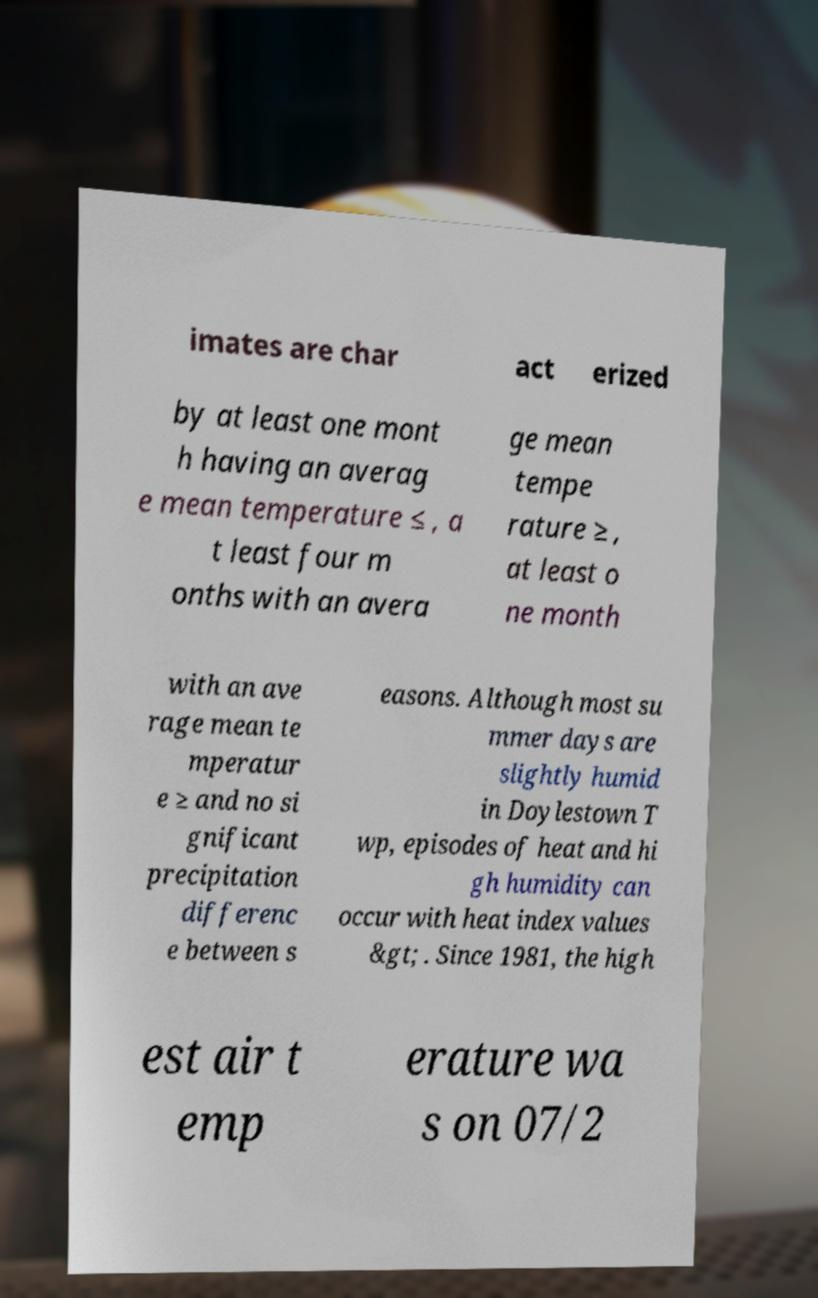Please read and relay the text visible in this image. What does it say? imates are char act erized by at least one mont h having an averag e mean temperature ≤ , a t least four m onths with an avera ge mean tempe rature ≥ , at least o ne month with an ave rage mean te mperatur e ≥ and no si gnificant precipitation differenc e between s easons. Although most su mmer days are slightly humid in Doylestown T wp, episodes of heat and hi gh humidity can occur with heat index values &gt; . Since 1981, the high est air t emp erature wa s on 07/2 